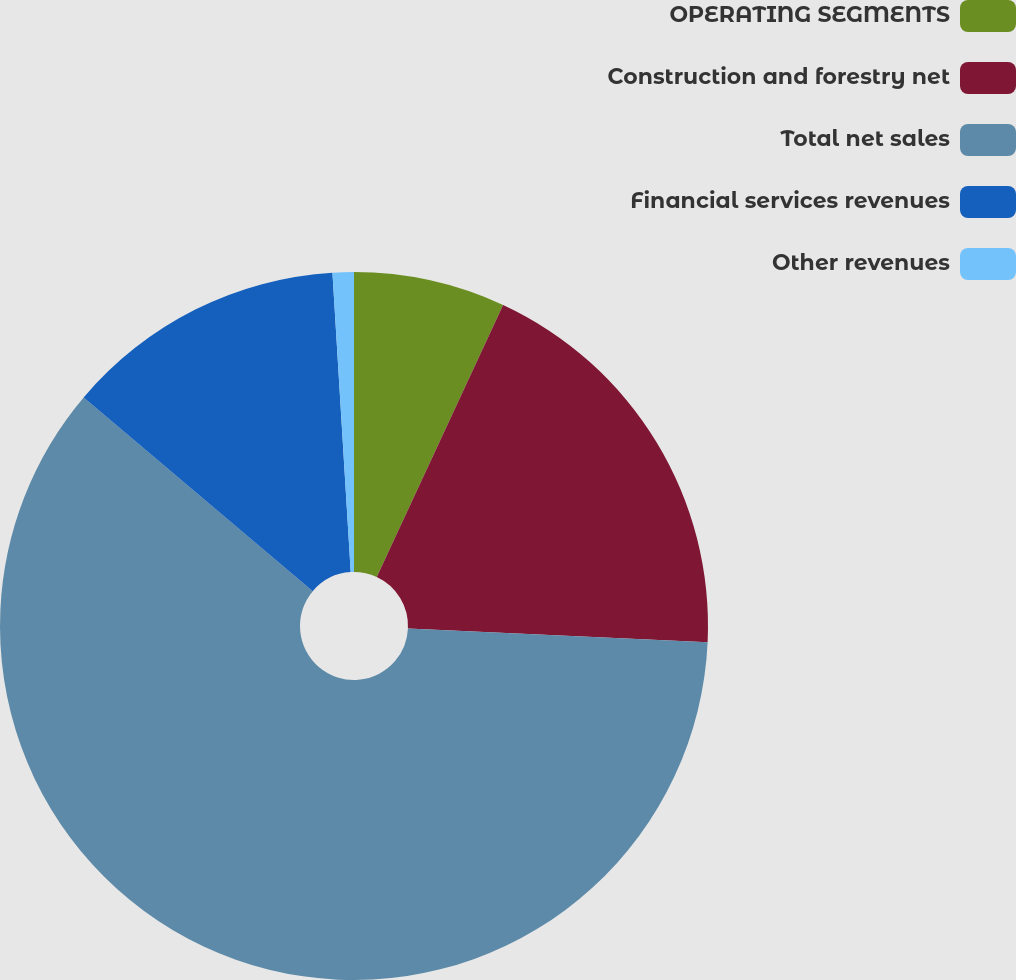Convert chart to OTSL. <chart><loc_0><loc_0><loc_500><loc_500><pie_chart><fcel>OPERATING SEGMENTS<fcel>Construction and forestry net<fcel>Total net sales<fcel>Financial services revenues<fcel>Other revenues<nl><fcel>6.92%<fcel>18.81%<fcel>60.44%<fcel>12.86%<fcel>0.97%<nl></chart> 